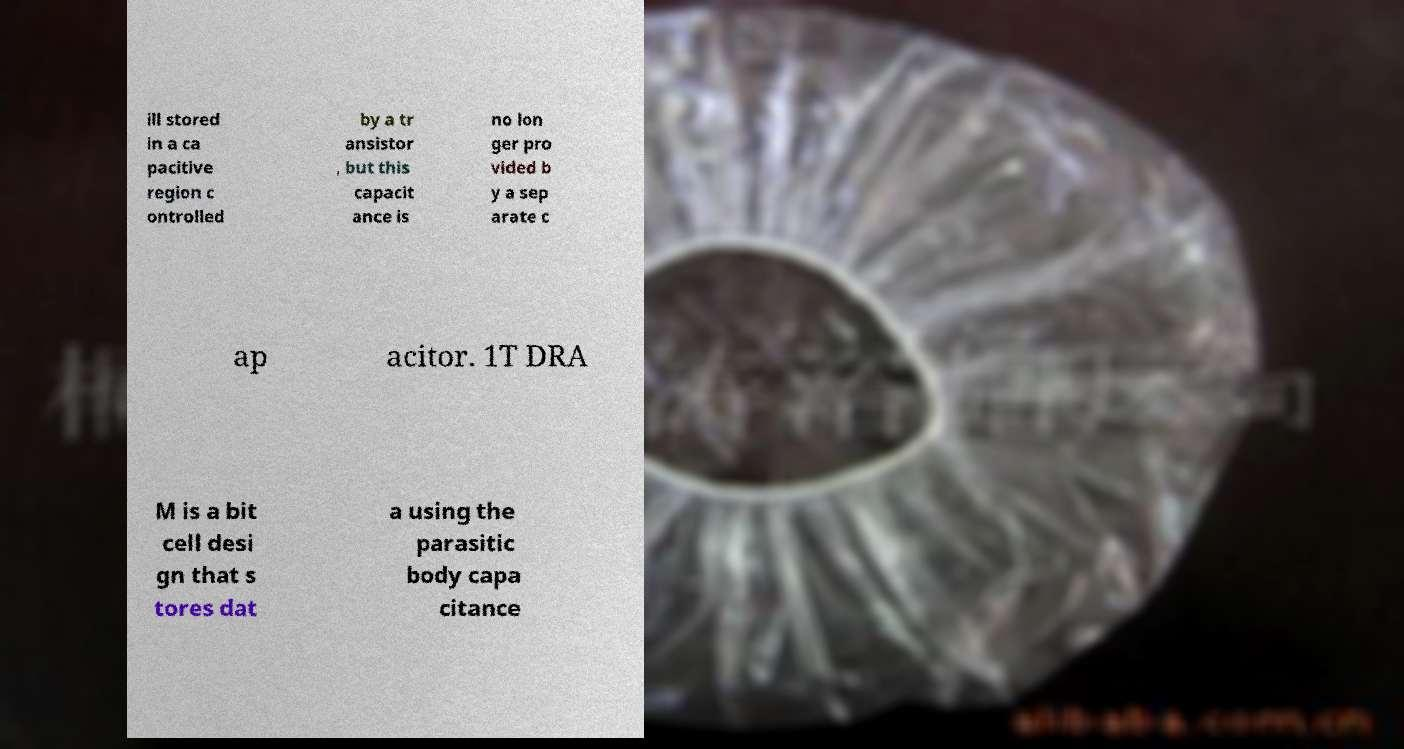There's text embedded in this image that I need extracted. Can you transcribe it verbatim? ill stored in a ca pacitive region c ontrolled by a tr ansistor , but this capacit ance is no lon ger pro vided b y a sep arate c ap acitor. 1T DRA M is a bit cell desi gn that s tores dat a using the parasitic body capa citance 